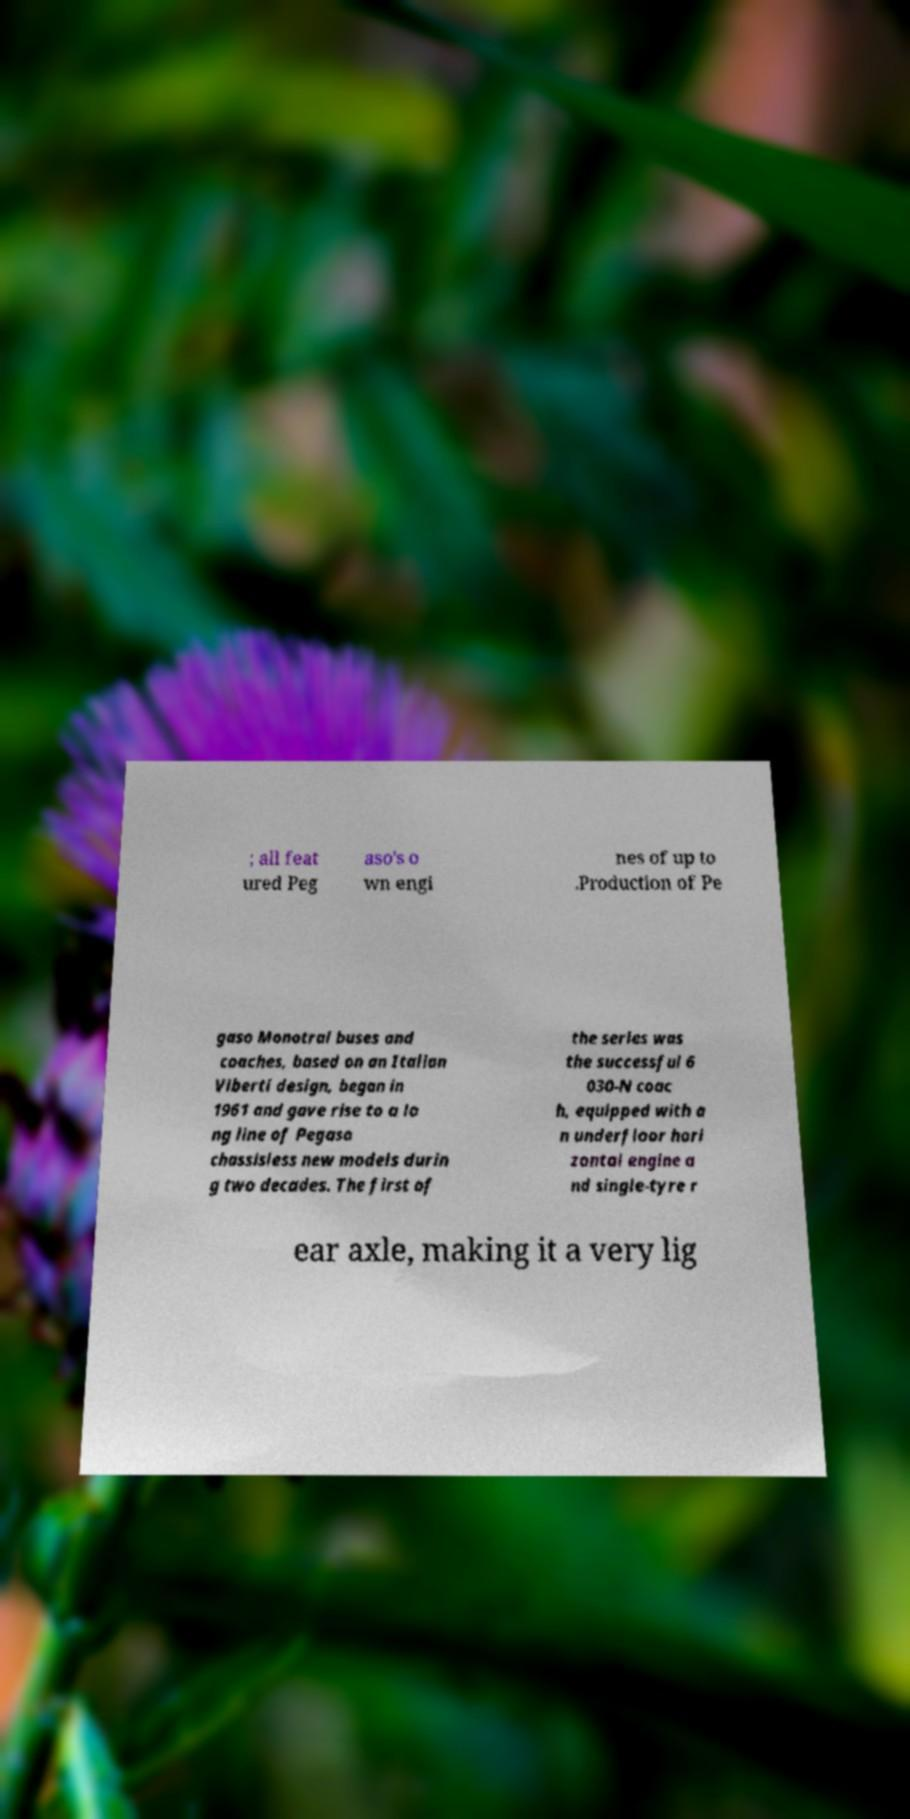Could you assist in decoding the text presented in this image and type it out clearly? ; all feat ured Peg aso's o wn engi nes of up to .Production of Pe gaso Monotral buses and coaches, based on an Italian Viberti design, began in 1961 and gave rise to a lo ng line of Pegaso chassisless new models durin g two decades. The first of the series was the successful 6 030-N coac h, equipped with a n underfloor hori zontal engine a nd single-tyre r ear axle, making it a very lig 